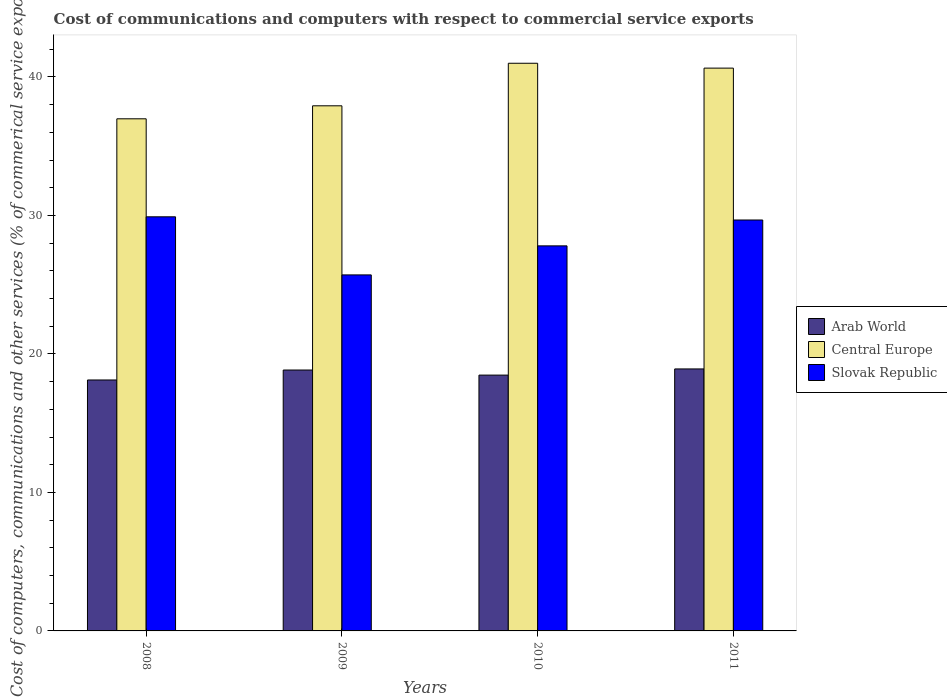How many different coloured bars are there?
Your answer should be very brief. 3. How many groups of bars are there?
Offer a very short reply. 4. Are the number of bars on each tick of the X-axis equal?
Make the answer very short. Yes. How many bars are there on the 3rd tick from the left?
Give a very brief answer. 3. How many bars are there on the 1st tick from the right?
Your answer should be compact. 3. What is the label of the 1st group of bars from the left?
Provide a succinct answer. 2008. What is the cost of communications and computers in Arab World in 2011?
Provide a short and direct response. 18.92. Across all years, what is the maximum cost of communications and computers in Slovak Republic?
Make the answer very short. 29.9. Across all years, what is the minimum cost of communications and computers in Slovak Republic?
Provide a succinct answer. 25.71. What is the total cost of communications and computers in Arab World in the graph?
Ensure brevity in your answer.  74.34. What is the difference between the cost of communications and computers in Central Europe in 2009 and that in 2010?
Your answer should be very brief. -3.07. What is the difference between the cost of communications and computers in Slovak Republic in 2011 and the cost of communications and computers in Central Europe in 2009?
Make the answer very short. -8.25. What is the average cost of communications and computers in Central Europe per year?
Provide a short and direct response. 39.13. In the year 2011, what is the difference between the cost of communications and computers in Slovak Republic and cost of communications and computers in Central Europe?
Offer a terse response. -10.97. In how many years, is the cost of communications and computers in Central Europe greater than 30 %?
Your answer should be very brief. 4. What is the ratio of the cost of communications and computers in Central Europe in 2010 to that in 2011?
Make the answer very short. 1.01. Is the cost of communications and computers in Arab World in 2010 less than that in 2011?
Provide a succinct answer. Yes. What is the difference between the highest and the second highest cost of communications and computers in Arab World?
Your response must be concise. 0.08. What is the difference between the highest and the lowest cost of communications and computers in Slovak Republic?
Give a very brief answer. 4.19. In how many years, is the cost of communications and computers in Arab World greater than the average cost of communications and computers in Arab World taken over all years?
Keep it short and to the point. 2. Is the sum of the cost of communications and computers in Central Europe in 2008 and 2011 greater than the maximum cost of communications and computers in Slovak Republic across all years?
Keep it short and to the point. Yes. What does the 1st bar from the left in 2010 represents?
Your answer should be very brief. Arab World. What does the 1st bar from the right in 2008 represents?
Ensure brevity in your answer.  Slovak Republic. How many bars are there?
Your answer should be very brief. 12. Are all the bars in the graph horizontal?
Make the answer very short. No. How many years are there in the graph?
Offer a very short reply. 4. Does the graph contain any zero values?
Offer a very short reply. No. Where does the legend appear in the graph?
Provide a short and direct response. Center right. How many legend labels are there?
Your answer should be very brief. 3. What is the title of the graph?
Make the answer very short. Cost of communications and computers with respect to commercial service exports. Does "Ecuador" appear as one of the legend labels in the graph?
Offer a very short reply. No. What is the label or title of the X-axis?
Ensure brevity in your answer.  Years. What is the label or title of the Y-axis?
Your answer should be very brief. Cost of computers, communications and other services (% of commerical service exports). What is the Cost of computers, communications and other services (% of commerical service exports) in Arab World in 2008?
Provide a short and direct response. 18.12. What is the Cost of computers, communications and other services (% of commerical service exports) in Central Europe in 2008?
Provide a short and direct response. 36.98. What is the Cost of computers, communications and other services (% of commerical service exports) in Slovak Republic in 2008?
Your response must be concise. 29.9. What is the Cost of computers, communications and other services (% of commerical service exports) of Arab World in 2009?
Make the answer very short. 18.84. What is the Cost of computers, communications and other services (% of commerical service exports) in Central Europe in 2009?
Make the answer very short. 37.91. What is the Cost of computers, communications and other services (% of commerical service exports) of Slovak Republic in 2009?
Your answer should be very brief. 25.71. What is the Cost of computers, communications and other services (% of commerical service exports) in Arab World in 2010?
Offer a very short reply. 18.47. What is the Cost of computers, communications and other services (% of commerical service exports) of Central Europe in 2010?
Keep it short and to the point. 40.99. What is the Cost of computers, communications and other services (% of commerical service exports) of Slovak Republic in 2010?
Provide a short and direct response. 27.8. What is the Cost of computers, communications and other services (% of commerical service exports) in Arab World in 2011?
Your answer should be compact. 18.92. What is the Cost of computers, communications and other services (% of commerical service exports) of Central Europe in 2011?
Your answer should be very brief. 40.64. What is the Cost of computers, communications and other services (% of commerical service exports) of Slovak Republic in 2011?
Offer a very short reply. 29.67. Across all years, what is the maximum Cost of computers, communications and other services (% of commerical service exports) of Arab World?
Provide a succinct answer. 18.92. Across all years, what is the maximum Cost of computers, communications and other services (% of commerical service exports) in Central Europe?
Make the answer very short. 40.99. Across all years, what is the maximum Cost of computers, communications and other services (% of commerical service exports) in Slovak Republic?
Keep it short and to the point. 29.9. Across all years, what is the minimum Cost of computers, communications and other services (% of commerical service exports) of Arab World?
Provide a succinct answer. 18.12. Across all years, what is the minimum Cost of computers, communications and other services (% of commerical service exports) of Central Europe?
Your response must be concise. 36.98. Across all years, what is the minimum Cost of computers, communications and other services (% of commerical service exports) of Slovak Republic?
Ensure brevity in your answer.  25.71. What is the total Cost of computers, communications and other services (% of commerical service exports) in Arab World in the graph?
Offer a very short reply. 74.34. What is the total Cost of computers, communications and other services (% of commerical service exports) in Central Europe in the graph?
Offer a very short reply. 156.51. What is the total Cost of computers, communications and other services (% of commerical service exports) of Slovak Republic in the graph?
Provide a succinct answer. 113.08. What is the difference between the Cost of computers, communications and other services (% of commerical service exports) in Arab World in 2008 and that in 2009?
Your answer should be compact. -0.72. What is the difference between the Cost of computers, communications and other services (% of commerical service exports) of Central Europe in 2008 and that in 2009?
Offer a very short reply. -0.94. What is the difference between the Cost of computers, communications and other services (% of commerical service exports) in Slovak Republic in 2008 and that in 2009?
Your response must be concise. 4.19. What is the difference between the Cost of computers, communications and other services (% of commerical service exports) of Arab World in 2008 and that in 2010?
Your answer should be compact. -0.35. What is the difference between the Cost of computers, communications and other services (% of commerical service exports) in Central Europe in 2008 and that in 2010?
Provide a short and direct response. -4.01. What is the difference between the Cost of computers, communications and other services (% of commerical service exports) in Slovak Republic in 2008 and that in 2010?
Offer a very short reply. 2.1. What is the difference between the Cost of computers, communications and other services (% of commerical service exports) of Arab World in 2008 and that in 2011?
Your answer should be compact. -0.8. What is the difference between the Cost of computers, communications and other services (% of commerical service exports) in Central Europe in 2008 and that in 2011?
Give a very brief answer. -3.66. What is the difference between the Cost of computers, communications and other services (% of commerical service exports) in Slovak Republic in 2008 and that in 2011?
Provide a short and direct response. 0.23. What is the difference between the Cost of computers, communications and other services (% of commerical service exports) in Arab World in 2009 and that in 2010?
Provide a succinct answer. 0.37. What is the difference between the Cost of computers, communications and other services (% of commerical service exports) in Central Europe in 2009 and that in 2010?
Your response must be concise. -3.07. What is the difference between the Cost of computers, communications and other services (% of commerical service exports) of Slovak Republic in 2009 and that in 2010?
Provide a succinct answer. -2.1. What is the difference between the Cost of computers, communications and other services (% of commerical service exports) of Arab World in 2009 and that in 2011?
Make the answer very short. -0.08. What is the difference between the Cost of computers, communications and other services (% of commerical service exports) in Central Europe in 2009 and that in 2011?
Provide a short and direct response. -2.72. What is the difference between the Cost of computers, communications and other services (% of commerical service exports) of Slovak Republic in 2009 and that in 2011?
Keep it short and to the point. -3.96. What is the difference between the Cost of computers, communications and other services (% of commerical service exports) in Arab World in 2010 and that in 2011?
Provide a short and direct response. -0.44. What is the difference between the Cost of computers, communications and other services (% of commerical service exports) in Central Europe in 2010 and that in 2011?
Provide a short and direct response. 0.35. What is the difference between the Cost of computers, communications and other services (% of commerical service exports) of Slovak Republic in 2010 and that in 2011?
Your answer should be very brief. -1.87. What is the difference between the Cost of computers, communications and other services (% of commerical service exports) in Arab World in 2008 and the Cost of computers, communications and other services (% of commerical service exports) in Central Europe in 2009?
Keep it short and to the point. -19.8. What is the difference between the Cost of computers, communications and other services (% of commerical service exports) in Arab World in 2008 and the Cost of computers, communications and other services (% of commerical service exports) in Slovak Republic in 2009?
Provide a short and direct response. -7.59. What is the difference between the Cost of computers, communications and other services (% of commerical service exports) of Central Europe in 2008 and the Cost of computers, communications and other services (% of commerical service exports) of Slovak Republic in 2009?
Offer a terse response. 11.27. What is the difference between the Cost of computers, communications and other services (% of commerical service exports) in Arab World in 2008 and the Cost of computers, communications and other services (% of commerical service exports) in Central Europe in 2010?
Ensure brevity in your answer.  -22.87. What is the difference between the Cost of computers, communications and other services (% of commerical service exports) in Arab World in 2008 and the Cost of computers, communications and other services (% of commerical service exports) in Slovak Republic in 2010?
Keep it short and to the point. -9.68. What is the difference between the Cost of computers, communications and other services (% of commerical service exports) in Central Europe in 2008 and the Cost of computers, communications and other services (% of commerical service exports) in Slovak Republic in 2010?
Your answer should be compact. 9.17. What is the difference between the Cost of computers, communications and other services (% of commerical service exports) in Arab World in 2008 and the Cost of computers, communications and other services (% of commerical service exports) in Central Europe in 2011?
Ensure brevity in your answer.  -22.52. What is the difference between the Cost of computers, communications and other services (% of commerical service exports) of Arab World in 2008 and the Cost of computers, communications and other services (% of commerical service exports) of Slovak Republic in 2011?
Provide a short and direct response. -11.55. What is the difference between the Cost of computers, communications and other services (% of commerical service exports) in Central Europe in 2008 and the Cost of computers, communications and other services (% of commerical service exports) in Slovak Republic in 2011?
Make the answer very short. 7.31. What is the difference between the Cost of computers, communications and other services (% of commerical service exports) of Arab World in 2009 and the Cost of computers, communications and other services (% of commerical service exports) of Central Europe in 2010?
Provide a succinct answer. -22.15. What is the difference between the Cost of computers, communications and other services (% of commerical service exports) in Arab World in 2009 and the Cost of computers, communications and other services (% of commerical service exports) in Slovak Republic in 2010?
Offer a terse response. -8.96. What is the difference between the Cost of computers, communications and other services (% of commerical service exports) in Central Europe in 2009 and the Cost of computers, communications and other services (% of commerical service exports) in Slovak Republic in 2010?
Your response must be concise. 10.11. What is the difference between the Cost of computers, communications and other services (% of commerical service exports) in Arab World in 2009 and the Cost of computers, communications and other services (% of commerical service exports) in Central Europe in 2011?
Keep it short and to the point. -21.8. What is the difference between the Cost of computers, communications and other services (% of commerical service exports) in Arab World in 2009 and the Cost of computers, communications and other services (% of commerical service exports) in Slovak Republic in 2011?
Give a very brief answer. -10.83. What is the difference between the Cost of computers, communications and other services (% of commerical service exports) of Central Europe in 2009 and the Cost of computers, communications and other services (% of commerical service exports) of Slovak Republic in 2011?
Provide a succinct answer. 8.25. What is the difference between the Cost of computers, communications and other services (% of commerical service exports) in Arab World in 2010 and the Cost of computers, communications and other services (% of commerical service exports) in Central Europe in 2011?
Your answer should be very brief. -22.16. What is the difference between the Cost of computers, communications and other services (% of commerical service exports) of Arab World in 2010 and the Cost of computers, communications and other services (% of commerical service exports) of Slovak Republic in 2011?
Your answer should be very brief. -11.2. What is the difference between the Cost of computers, communications and other services (% of commerical service exports) in Central Europe in 2010 and the Cost of computers, communications and other services (% of commerical service exports) in Slovak Republic in 2011?
Keep it short and to the point. 11.32. What is the average Cost of computers, communications and other services (% of commerical service exports) of Arab World per year?
Your response must be concise. 18.59. What is the average Cost of computers, communications and other services (% of commerical service exports) in Central Europe per year?
Keep it short and to the point. 39.13. What is the average Cost of computers, communications and other services (% of commerical service exports) of Slovak Republic per year?
Give a very brief answer. 28.27. In the year 2008, what is the difference between the Cost of computers, communications and other services (% of commerical service exports) of Arab World and Cost of computers, communications and other services (% of commerical service exports) of Central Europe?
Make the answer very short. -18.86. In the year 2008, what is the difference between the Cost of computers, communications and other services (% of commerical service exports) of Arab World and Cost of computers, communications and other services (% of commerical service exports) of Slovak Republic?
Keep it short and to the point. -11.78. In the year 2008, what is the difference between the Cost of computers, communications and other services (% of commerical service exports) of Central Europe and Cost of computers, communications and other services (% of commerical service exports) of Slovak Republic?
Your answer should be compact. 7.08. In the year 2009, what is the difference between the Cost of computers, communications and other services (% of commerical service exports) in Arab World and Cost of computers, communications and other services (% of commerical service exports) in Central Europe?
Make the answer very short. -19.08. In the year 2009, what is the difference between the Cost of computers, communications and other services (% of commerical service exports) of Arab World and Cost of computers, communications and other services (% of commerical service exports) of Slovak Republic?
Offer a terse response. -6.87. In the year 2009, what is the difference between the Cost of computers, communications and other services (% of commerical service exports) of Central Europe and Cost of computers, communications and other services (% of commerical service exports) of Slovak Republic?
Make the answer very short. 12.21. In the year 2010, what is the difference between the Cost of computers, communications and other services (% of commerical service exports) of Arab World and Cost of computers, communications and other services (% of commerical service exports) of Central Europe?
Give a very brief answer. -22.52. In the year 2010, what is the difference between the Cost of computers, communications and other services (% of commerical service exports) of Arab World and Cost of computers, communications and other services (% of commerical service exports) of Slovak Republic?
Ensure brevity in your answer.  -9.33. In the year 2010, what is the difference between the Cost of computers, communications and other services (% of commerical service exports) in Central Europe and Cost of computers, communications and other services (% of commerical service exports) in Slovak Republic?
Ensure brevity in your answer.  13.18. In the year 2011, what is the difference between the Cost of computers, communications and other services (% of commerical service exports) of Arab World and Cost of computers, communications and other services (% of commerical service exports) of Central Europe?
Give a very brief answer. -21.72. In the year 2011, what is the difference between the Cost of computers, communications and other services (% of commerical service exports) of Arab World and Cost of computers, communications and other services (% of commerical service exports) of Slovak Republic?
Provide a succinct answer. -10.75. In the year 2011, what is the difference between the Cost of computers, communications and other services (% of commerical service exports) of Central Europe and Cost of computers, communications and other services (% of commerical service exports) of Slovak Republic?
Keep it short and to the point. 10.97. What is the ratio of the Cost of computers, communications and other services (% of commerical service exports) of Arab World in 2008 to that in 2009?
Offer a terse response. 0.96. What is the ratio of the Cost of computers, communications and other services (% of commerical service exports) in Central Europe in 2008 to that in 2009?
Offer a terse response. 0.98. What is the ratio of the Cost of computers, communications and other services (% of commerical service exports) in Slovak Republic in 2008 to that in 2009?
Give a very brief answer. 1.16. What is the ratio of the Cost of computers, communications and other services (% of commerical service exports) of Arab World in 2008 to that in 2010?
Provide a succinct answer. 0.98. What is the ratio of the Cost of computers, communications and other services (% of commerical service exports) of Central Europe in 2008 to that in 2010?
Offer a terse response. 0.9. What is the ratio of the Cost of computers, communications and other services (% of commerical service exports) in Slovak Republic in 2008 to that in 2010?
Make the answer very short. 1.08. What is the ratio of the Cost of computers, communications and other services (% of commerical service exports) in Arab World in 2008 to that in 2011?
Keep it short and to the point. 0.96. What is the ratio of the Cost of computers, communications and other services (% of commerical service exports) of Central Europe in 2008 to that in 2011?
Offer a very short reply. 0.91. What is the ratio of the Cost of computers, communications and other services (% of commerical service exports) in Slovak Republic in 2008 to that in 2011?
Keep it short and to the point. 1.01. What is the ratio of the Cost of computers, communications and other services (% of commerical service exports) of Arab World in 2009 to that in 2010?
Your response must be concise. 1.02. What is the ratio of the Cost of computers, communications and other services (% of commerical service exports) of Central Europe in 2009 to that in 2010?
Make the answer very short. 0.93. What is the ratio of the Cost of computers, communications and other services (% of commerical service exports) in Slovak Republic in 2009 to that in 2010?
Your response must be concise. 0.92. What is the ratio of the Cost of computers, communications and other services (% of commerical service exports) of Central Europe in 2009 to that in 2011?
Ensure brevity in your answer.  0.93. What is the ratio of the Cost of computers, communications and other services (% of commerical service exports) in Slovak Republic in 2009 to that in 2011?
Make the answer very short. 0.87. What is the ratio of the Cost of computers, communications and other services (% of commerical service exports) of Arab World in 2010 to that in 2011?
Give a very brief answer. 0.98. What is the ratio of the Cost of computers, communications and other services (% of commerical service exports) of Central Europe in 2010 to that in 2011?
Give a very brief answer. 1.01. What is the ratio of the Cost of computers, communications and other services (% of commerical service exports) in Slovak Republic in 2010 to that in 2011?
Keep it short and to the point. 0.94. What is the difference between the highest and the second highest Cost of computers, communications and other services (% of commerical service exports) of Arab World?
Your answer should be compact. 0.08. What is the difference between the highest and the second highest Cost of computers, communications and other services (% of commerical service exports) of Central Europe?
Offer a terse response. 0.35. What is the difference between the highest and the second highest Cost of computers, communications and other services (% of commerical service exports) in Slovak Republic?
Offer a terse response. 0.23. What is the difference between the highest and the lowest Cost of computers, communications and other services (% of commerical service exports) in Arab World?
Provide a short and direct response. 0.8. What is the difference between the highest and the lowest Cost of computers, communications and other services (% of commerical service exports) of Central Europe?
Provide a succinct answer. 4.01. What is the difference between the highest and the lowest Cost of computers, communications and other services (% of commerical service exports) in Slovak Republic?
Your answer should be compact. 4.19. 